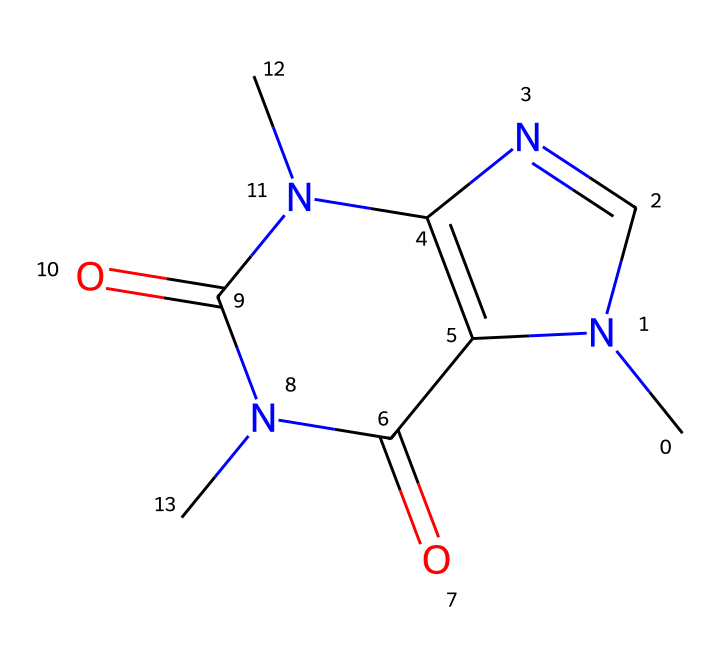What is the molecular formula of caffeine? To find the molecular formula, identify the number of each type of atom present in the structure. The structure contains 8 carbons (C), 10 hydrogens (H), 4 nitrogens (N), and 4 oxygens (O). Thus, the molecular formula is C8H10N4O2.
Answer: C8H10N4O2 How many nitrogen atoms are in caffeine? Count the nitrogen (N) atoms in the chemical structure. There are 4 nitrogen atoms present in the structure.
Answer: 4 Is caffeine a hazardous chemical? Caffeine can be classified as hazardous due to its stimulant properties and potential toxic effects in high doses. Therefore, it is necessary to manage its exposure carefully.
Answer: yes What type of bonding is most prevalent in caffeine? The structure shows that caffeine contains mainly covalent bonds, as evidenced by the connections between carbon, nitrogen, and oxygen atoms.
Answer: covalent What does the presence of nitrogen atoms indicate about caffeine’s properties? The presence of nitrogen atoms often indicates that a chemical is an alkaloid, which are typically known for their physiological activity, including stimulant effects.
Answer: alkaloid How many rings are present in the caffeine structure? Analyze the structure to identify any cycles or rings formed by the atoms. Caffeine has two fused rings in its structure.
Answer: 2 